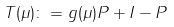Convert formula to latex. <formula><loc_0><loc_0><loc_500><loc_500>T ( \mu ) \colon = g ( \mu ) P + I - P</formula> 